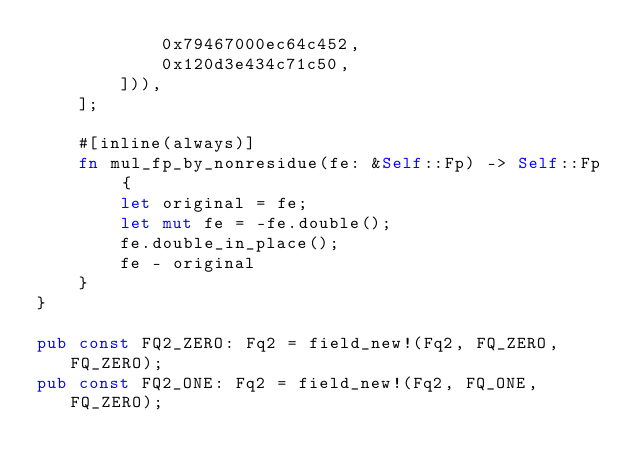<code> <loc_0><loc_0><loc_500><loc_500><_Rust_>            0x79467000ec64c452,
            0x120d3e434c71c50,
        ])),
    ];

    #[inline(always)]
    fn mul_fp_by_nonresidue(fe: &Self::Fp) -> Self::Fp {
        let original = fe;
        let mut fe = -fe.double();
        fe.double_in_place();
        fe - original
    }
}

pub const FQ2_ZERO: Fq2 = field_new!(Fq2, FQ_ZERO, FQ_ZERO);
pub const FQ2_ONE: Fq2 = field_new!(Fq2, FQ_ONE, FQ_ZERO);
</code> 